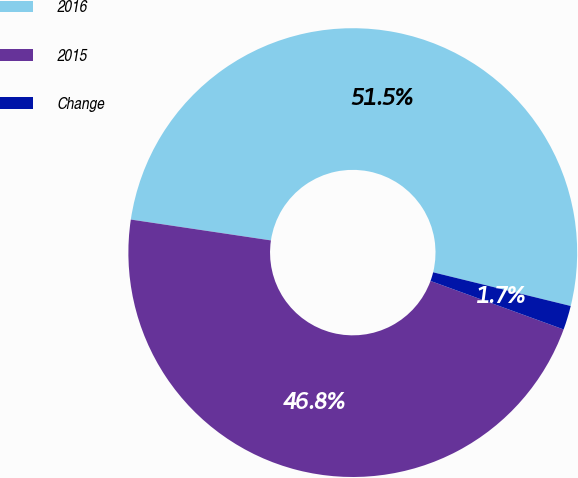<chart> <loc_0><loc_0><loc_500><loc_500><pie_chart><fcel>2016<fcel>2015<fcel>Change<nl><fcel>51.47%<fcel>46.79%<fcel>1.74%<nl></chart> 